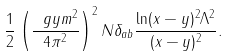Convert formula to latex. <formula><loc_0><loc_0><loc_500><loc_500>\frac { 1 } { 2 } \left ( \frac { \ g y m ^ { 2 } } { 4 \pi ^ { 2 } } \right ) ^ { 2 } N \delta _ { a b } \frac { \ln ( x - y ) ^ { 2 } \Lambda ^ { 2 } } { ( x - y ) ^ { 2 } } .</formula> 